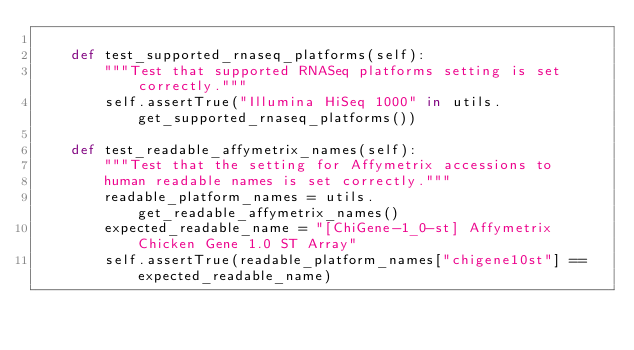Convert code to text. <code><loc_0><loc_0><loc_500><loc_500><_Python_>
    def test_supported_rnaseq_platforms(self):
        """Test that supported RNASeq platforms setting is set correctly."""
        self.assertTrue("Illumina HiSeq 1000" in utils.get_supported_rnaseq_platforms())

    def test_readable_affymetrix_names(self):
        """Test that the setting for Affymetrix accessions to
        human readable names is set correctly."""
        readable_platform_names = utils.get_readable_affymetrix_names()
        expected_readable_name = "[ChiGene-1_0-st] Affymetrix Chicken Gene 1.0 ST Array"
        self.assertTrue(readable_platform_names["chigene10st"] == expected_readable_name)</code> 